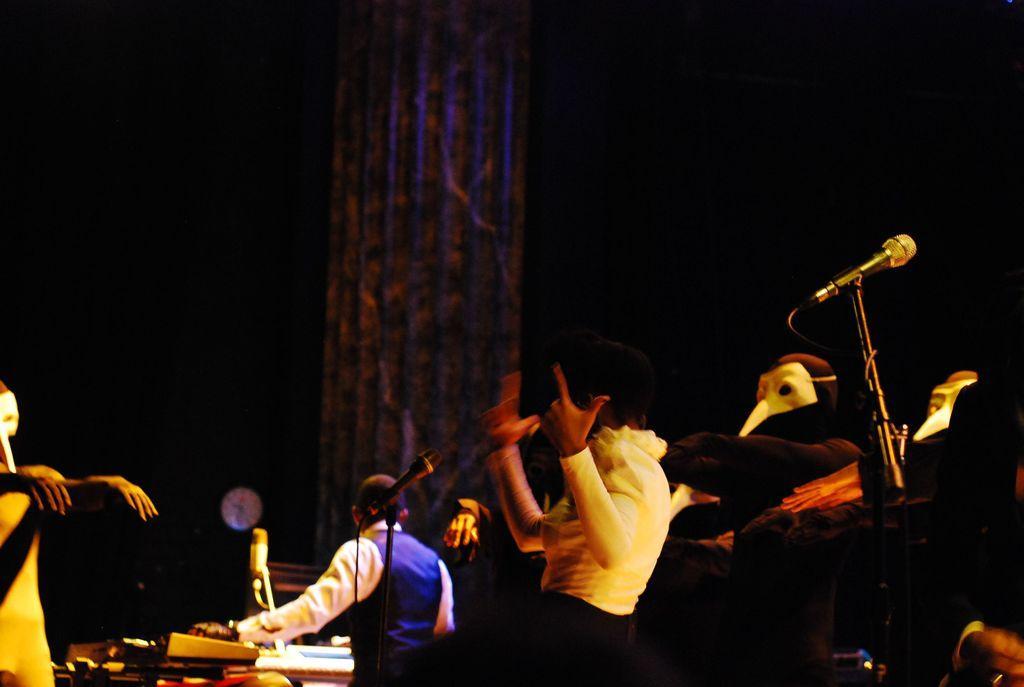Could you give a brief overview of what you see in this image? This image is taken in a music concert. There are people in the image. There are mics. 